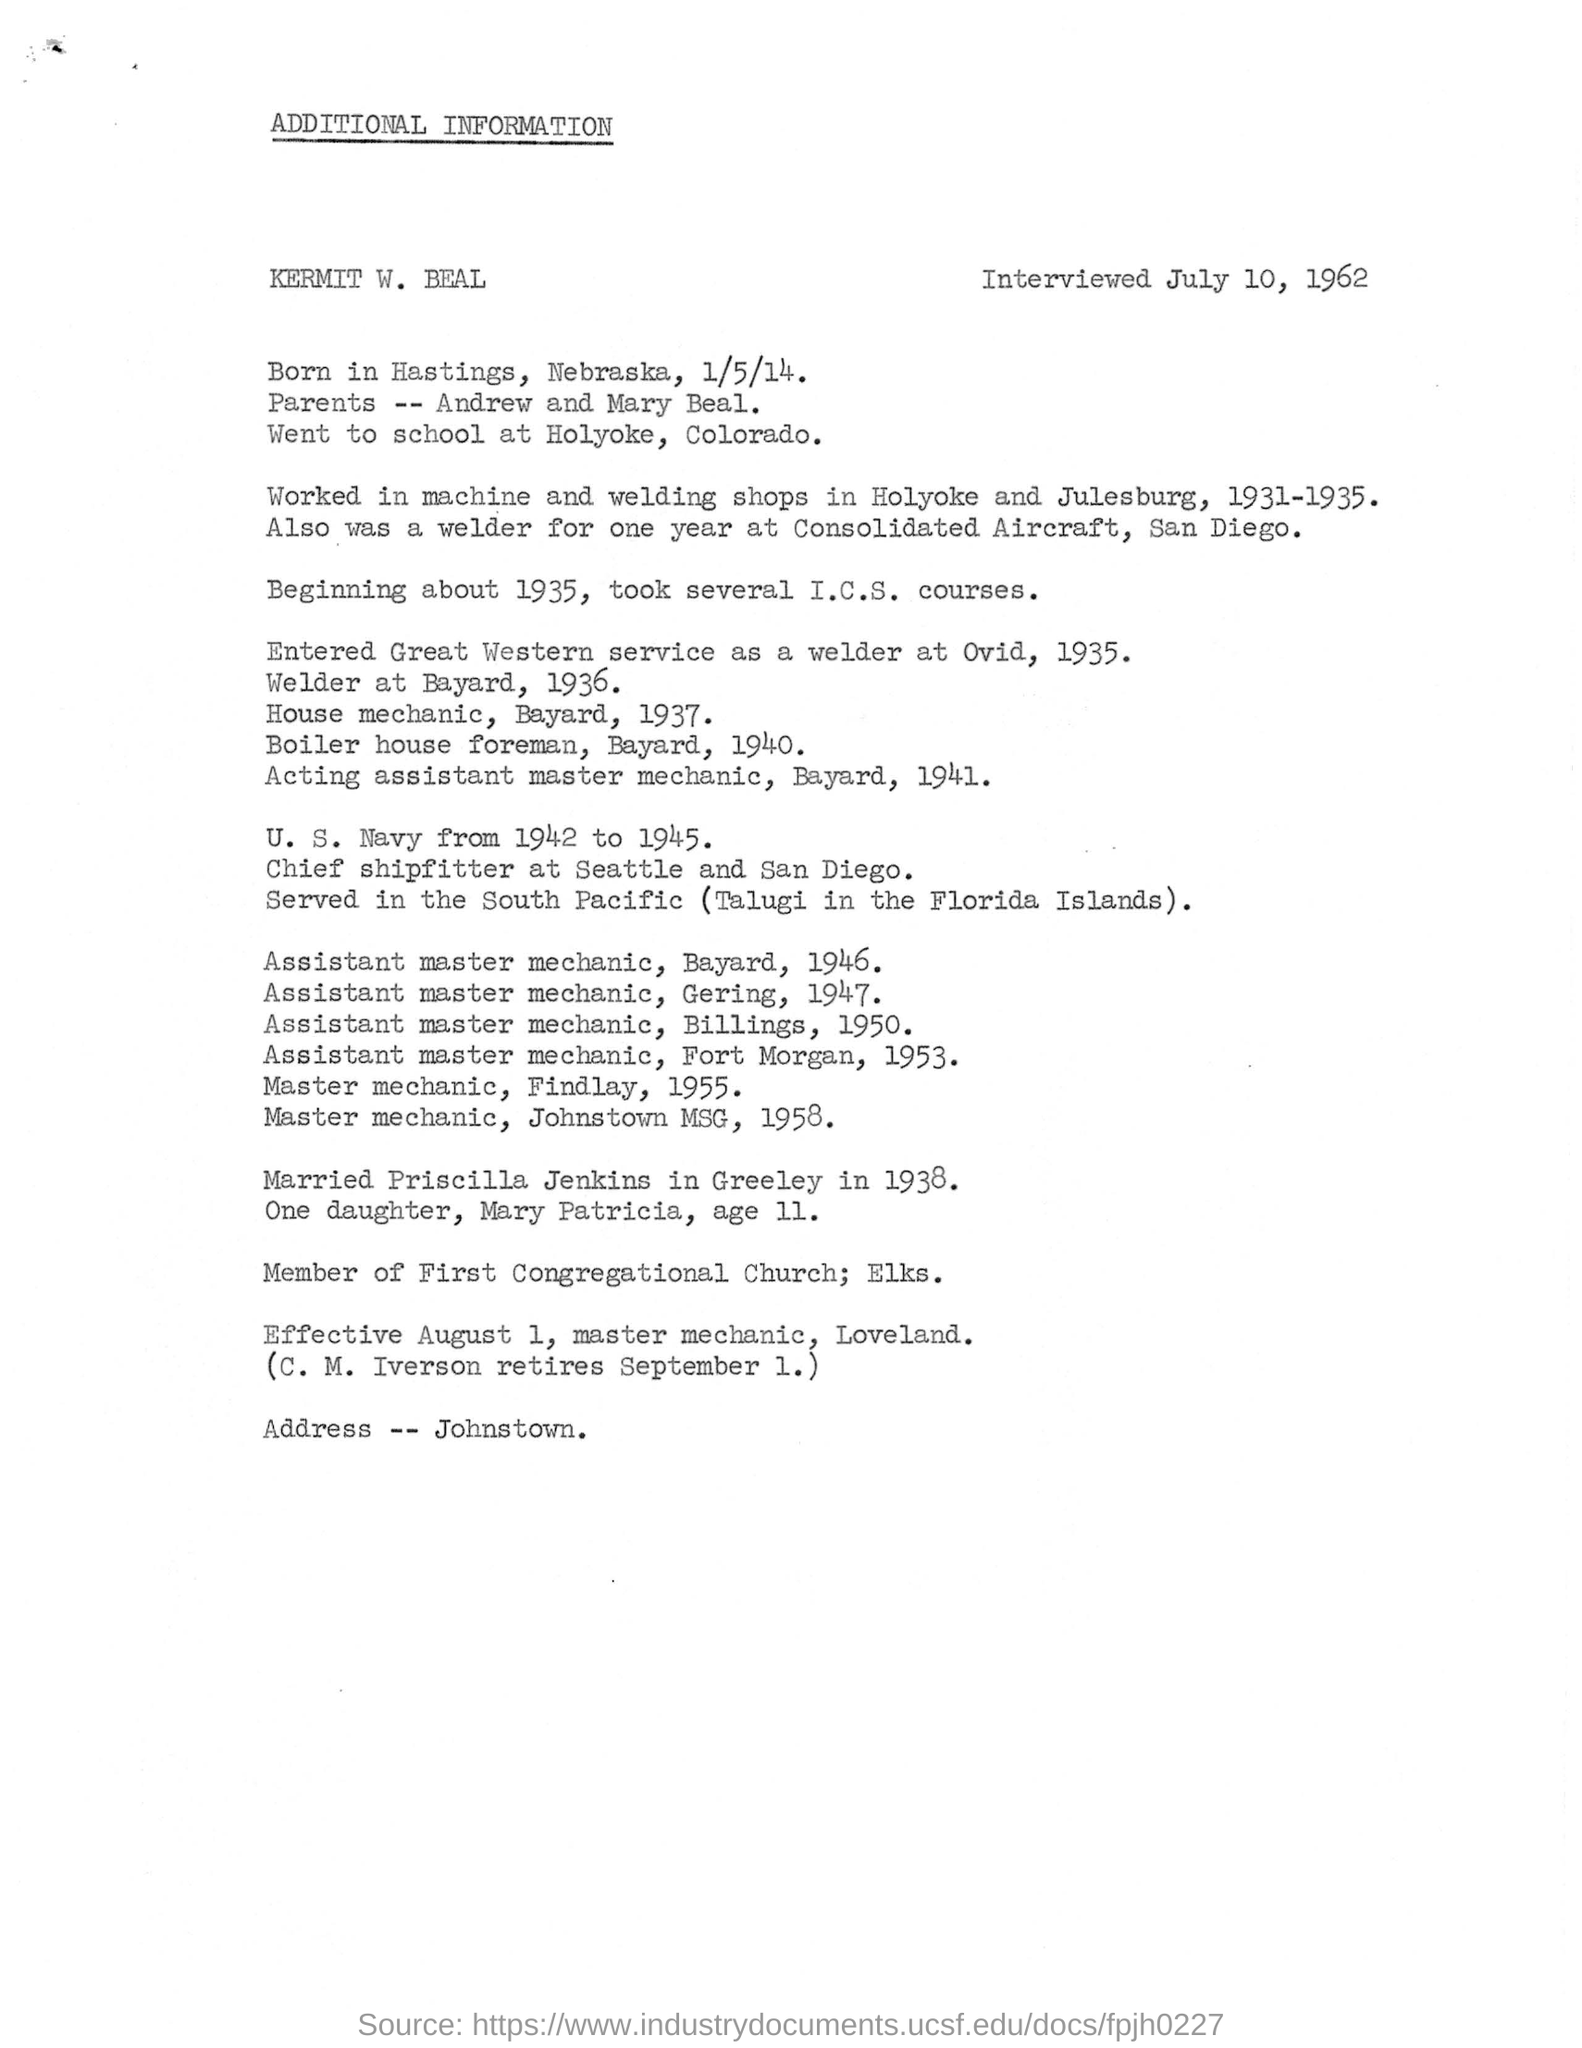Indicate a few pertinent items in this graphic. Kermit W. Beal served in the U.S. Navy from 1942 to 1945, during which period he made significant contributions to the war effort. Kermit W. Beal got married in 1938. Kermit W. Beal was born in Hastings, Nebraska. The date of birth of Kermit W. Beal is January 5, 2014. 